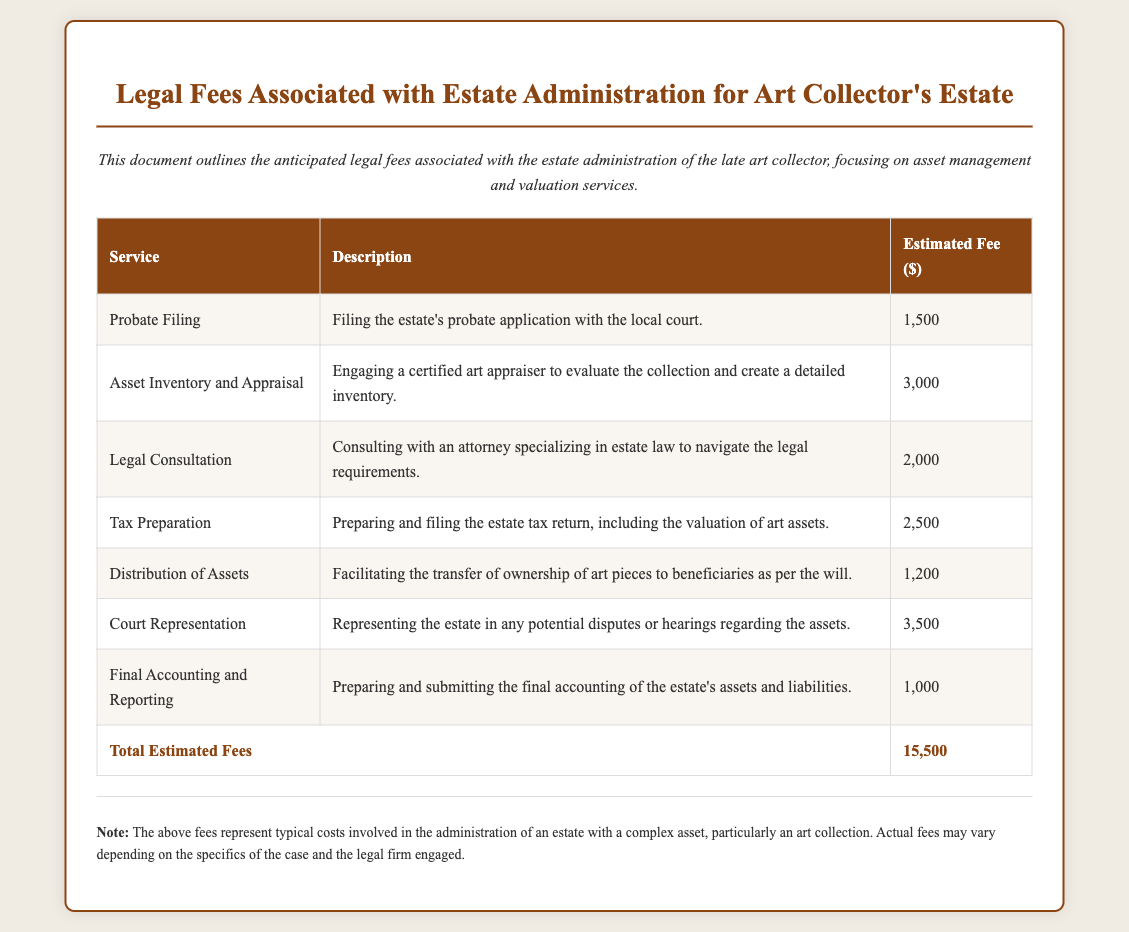What is the total estimated fee? The total estimated fee is found at the bottom of the fee table, summing all individual services.
Answer: 15,500 How much is the fee for asset inventory and appraisal? The fee for asset inventory and appraisal is listed in the table under the appropriate service.
Answer: 3,000 What service involves filing the probate application? The service responsible for filing the probate application is clearly labeled in the service column of the table.
Answer: Probate Filing Which service has the highest estimated fee? To identify the highest fee, review the estimated fees listed under each service and compare them.
Answer: Court Representation What is the description for the legal consultation service? The description for legal consultation can be found in the corresponding cell of the table.
Answer: Consulting with an attorney specializing in estate law to navigate the legal requirements What is the estimated fee for tax preparation? The estimated fee for tax preparation can be found in its respective row of the fee table.
Answer: 2,500 Which service is involved in distributing assets to beneficiaries? The service involved in distributing assets to beneficiaries is specified in the service column of the table.
Answer: Distribution of Assets What does the final accounting and reporting service entail? The details of the final accounting and reporting service are provided in the description column of the table.
Answer: Preparing and submitting the final accounting of the estate's assets and liabilities 